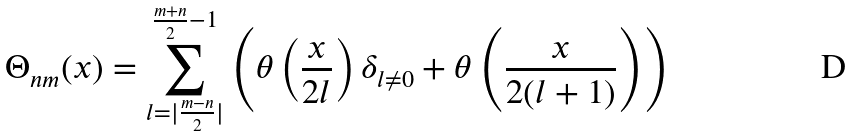Convert formula to latex. <formula><loc_0><loc_0><loc_500><loc_500>\Theta _ { n m } ( x ) = \sum _ { l = | \frac { m - n } { 2 } | } ^ { \frac { m + n } { 2 } - 1 } \left ( \theta \left ( \frac { x } { 2 l } \right ) \delta _ { l \neq 0 } + \theta \left ( \frac { x } { 2 ( l + 1 ) } \right ) \right )</formula> 